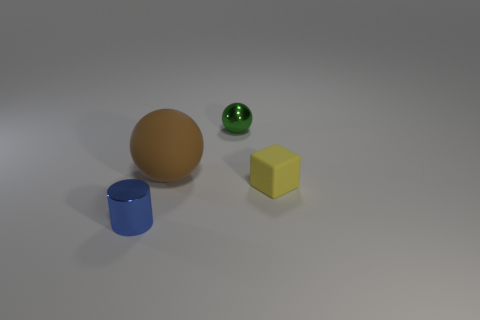Add 2 big brown matte objects. How many objects exist? 6 Subtract all cubes. How many objects are left? 3 Add 1 cubes. How many cubes exist? 2 Subtract 0 red blocks. How many objects are left? 4 Subtract all gray spheres. Subtract all big objects. How many objects are left? 3 Add 3 yellow rubber blocks. How many yellow rubber blocks are left? 4 